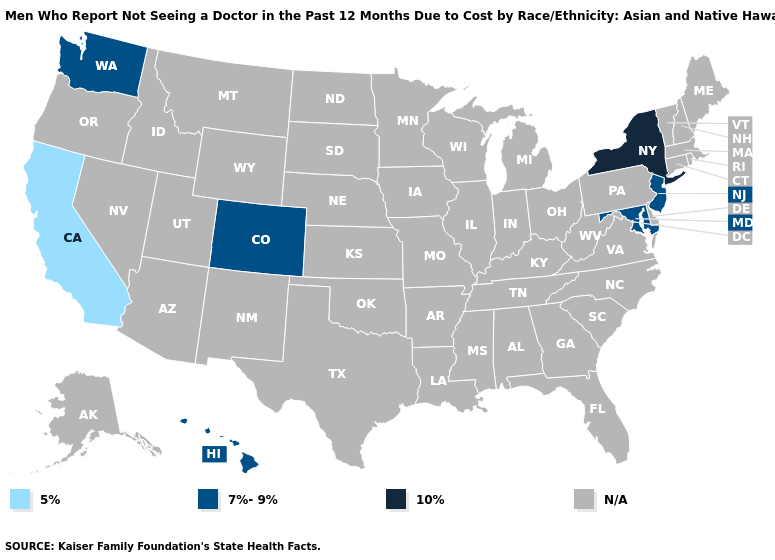Does California have the lowest value in the USA?
Keep it brief. Yes. What is the value of Pennsylvania?
Short answer required. N/A. What is the value of Idaho?
Keep it brief. N/A. What is the value of Vermont?
Give a very brief answer. N/A. Does Colorado have the lowest value in the USA?
Quick response, please. No. Name the states that have a value in the range 5%?
Concise answer only. California. What is the lowest value in states that border New York?
Answer briefly. 7%-9%. Name the states that have a value in the range N/A?
Answer briefly. Alabama, Alaska, Arizona, Arkansas, Connecticut, Delaware, Florida, Georgia, Idaho, Illinois, Indiana, Iowa, Kansas, Kentucky, Louisiana, Maine, Massachusetts, Michigan, Minnesota, Mississippi, Missouri, Montana, Nebraska, Nevada, New Hampshire, New Mexico, North Carolina, North Dakota, Ohio, Oklahoma, Oregon, Pennsylvania, Rhode Island, South Carolina, South Dakota, Tennessee, Texas, Utah, Vermont, Virginia, West Virginia, Wisconsin, Wyoming. Name the states that have a value in the range N/A?
Answer briefly. Alabama, Alaska, Arizona, Arkansas, Connecticut, Delaware, Florida, Georgia, Idaho, Illinois, Indiana, Iowa, Kansas, Kentucky, Louisiana, Maine, Massachusetts, Michigan, Minnesota, Mississippi, Missouri, Montana, Nebraska, Nevada, New Hampshire, New Mexico, North Carolina, North Dakota, Ohio, Oklahoma, Oregon, Pennsylvania, Rhode Island, South Carolina, South Dakota, Tennessee, Texas, Utah, Vermont, Virginia, West Virginia, Wisconsin, Wyoming. Which states have the lowest value in the USA?
Answer briefly. California. Name the states that have a value in the range 7%-9%?
Short answer required. Colorado, Hawaii, Maryland, New Jersey, Washington. What is the value of New Jersey?
Concise answer only. 7%-9%. Name the states that have a value in the range 5%?
Quick response, please. California. 